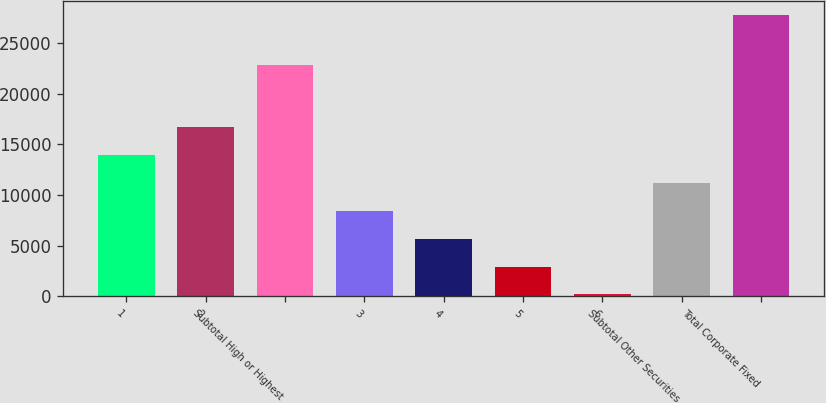Convert chart. <chart><loc_0><loc_0><loc_500><loc_500><bar_chart><fcel>1<fcel>2<fcel>Subtotal High or Highest<fcel>3<fcel>4<fcel>5<fcel>6<fcel>Subtotal Other Securities<fcel>Total Corporate Fixed<nl><fcel>13950.5<fcel>16701<fcel>22841<fcel>8449.5<fcel>5699<fcel>2948.5<fcel>198<fcel>11200<fcel>27703<nl></chart> 